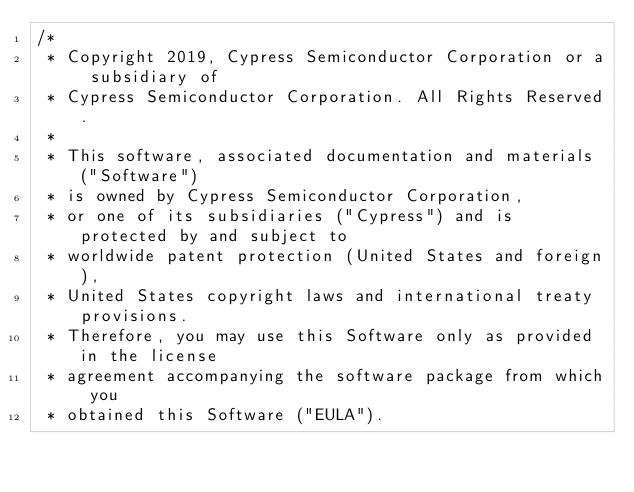<code> <loc_0><loc_0><loc_500><loc_500><_C_>/*
 * Copyright 2019, Cypress Semiconductor Corporation or a subsidiary of
 * Cypress Semiconductor Corporation. All Rights Reserved.
 * 
 * This software, associated documentation and materials ("Software")
 * is owned by Cypress Semiconductor Corporation,
 * or one of its subsidiaries ("Cypress") and is protected by and subject to
 * worldwide patent protection (United States and foreign),
 * United States copyright laws and international treaty provisions.
 * Therefore, you may use this Software only as provided in the license
 * agreement accompanying the software package from which you
 * obtained this Software ("EULA").</code> 